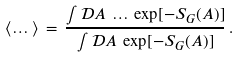<formula> <loc_0><loc_0><loc_500><loc_500>\langle \dots \rangle \, = \, \frac { \int { \mathcal { D } } A \, \dots \, \exp [ - S _ { G } ( A ) ] } { \int { \mathcal { D } } A \, \exp [ - S _ { G } ( A ) ] } \, .</formula> 